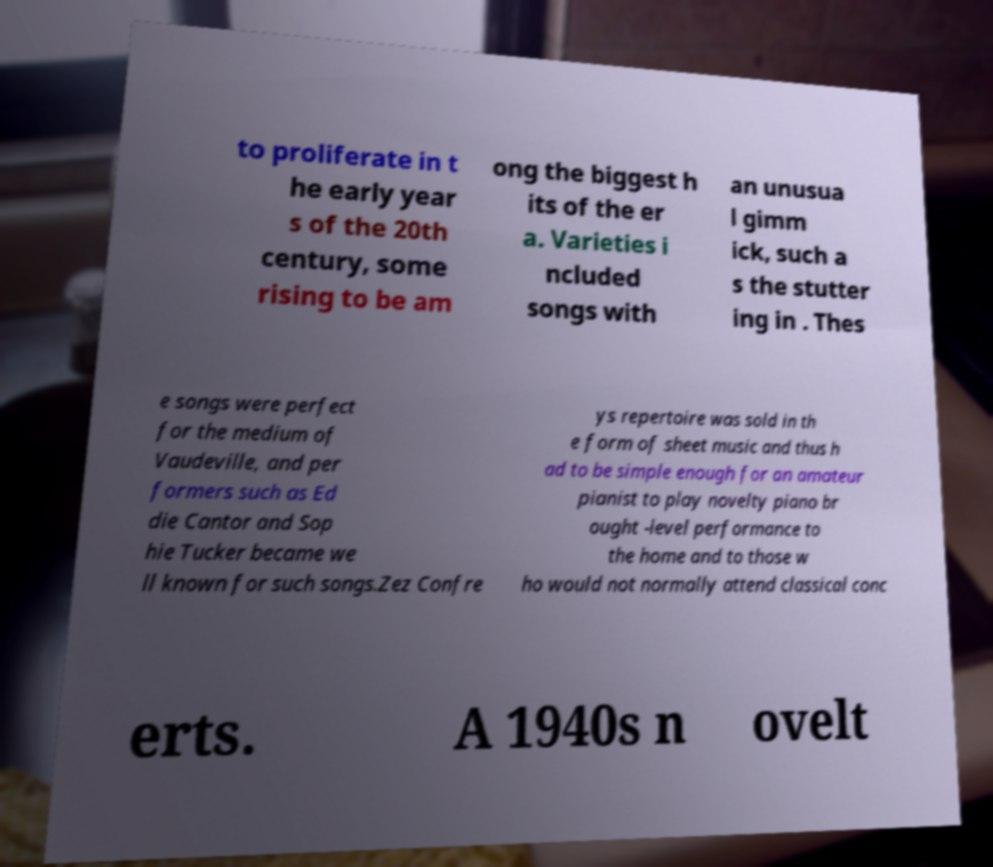Could you extract and type out the text from this image? to proliferate in t he early year s of the 20th century, some rising to be am ong the biggest h its of the er a. Varieties i ncluded songs with an unusua l gimm ick, such a s the stutter ing in . Thes e songs were perfect for the medium of Vaudeville, and per formers such as Ed die Cantor and Sop hie Tucker became we ll known for such songs.Zez Confre ys repertoire was sold in th e form of sheet music and thus h ad to be simple enough for an amateur pianist to play novelty piano br ought -level performance to the home and to those w ho would not normally attend classical conc erts. A 1940s n ovelt 